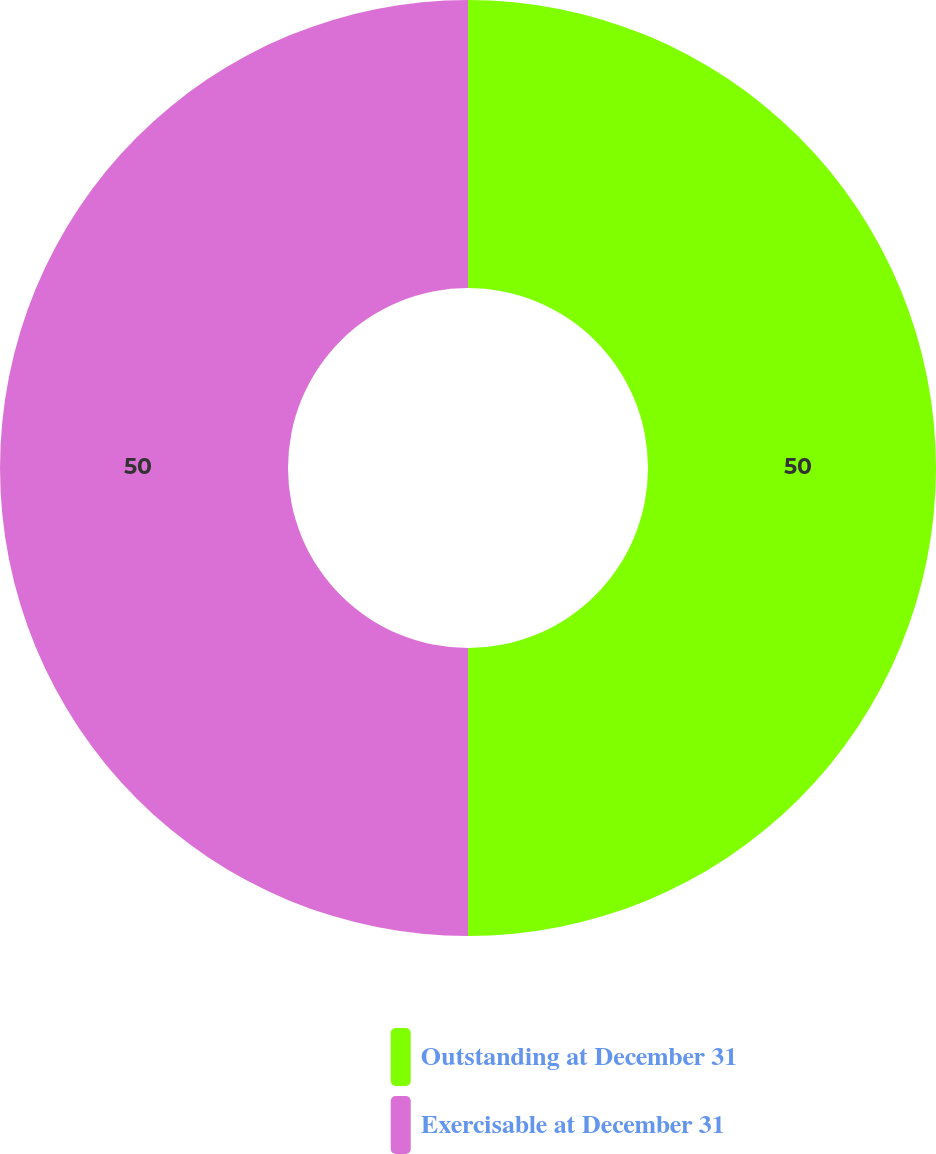<chart> <loc_0><loc_0><loc_500><loc_500><pie_chart><fcel>Outstanding at December 31<fcel>Exercisable at December 31<nl><fcel>50.0%<fcel>50.0%<nl></chart> 